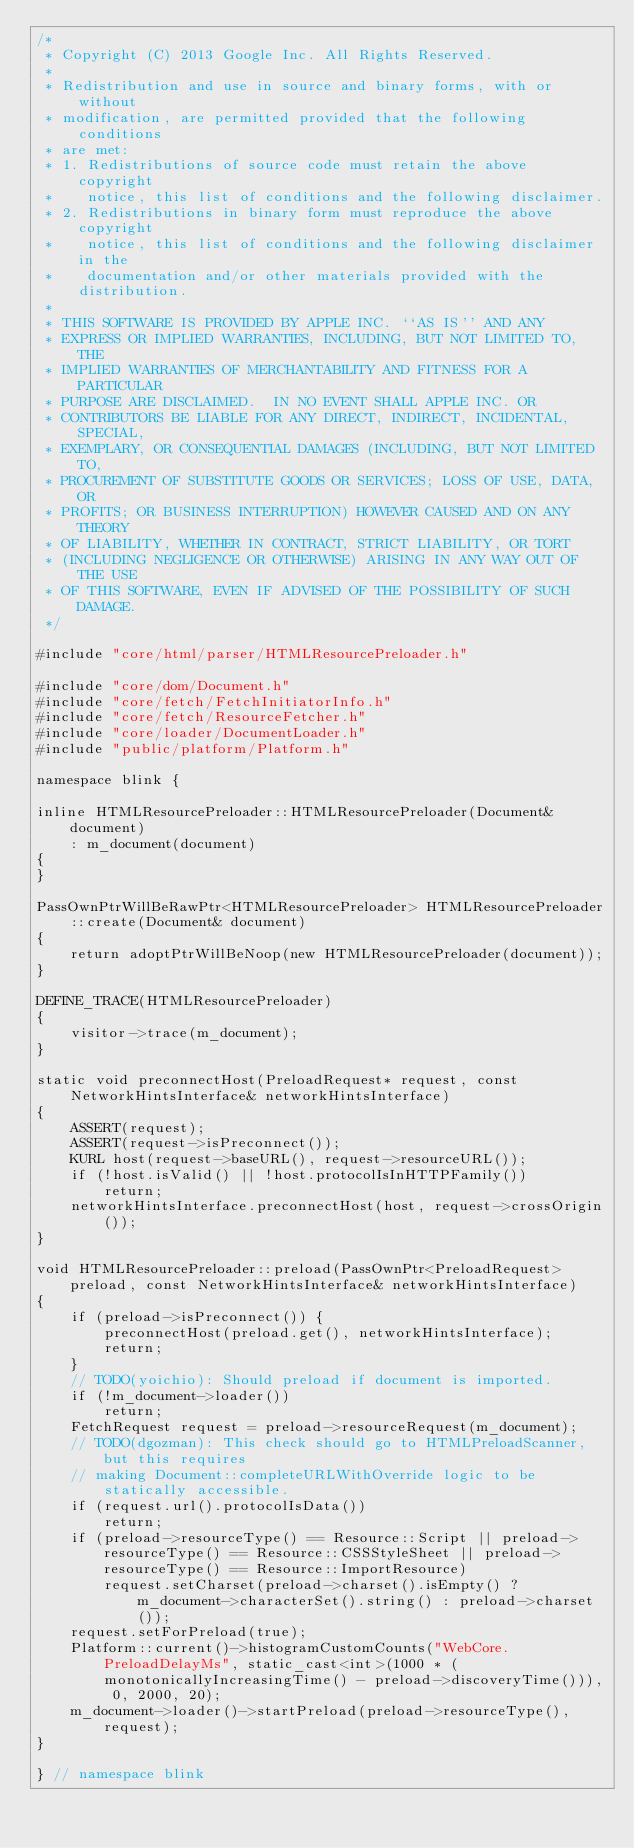Convert code to text. <code><loc_0><loc_0><loc_500><loc_500><_C++_>/*
 * Copyright (C) 2013 Google Inc. All Rights Reserved.
 *
 * Redistribution and use in source and binary forms, with or without
 * modification, are permitted provided that the following conditions
 * are met:
 * 1. Redistributions of source code must retain the above copyright
 *    notice, this list of conditions and the following disclaimer.
 * 2. Redistributions in binary form must reproduce the above copyright
 *    notice, this list of conditions and the following disclaimer in the
 *    documentation and/or other materials provided with the distribution.
 *
 * THIS SOFTWARE IS PROVIDED BY APPLE INC. ``AS IS'' AND ANY
 * EXPRESS OR IMPLIED WARRANTIES, INCLUDING, BUT NOT LIMITED TO, THE
 * IMPLIED WARRANTIES OF MERCHANTABILITY AND FITNESS FOR A PARTICULAR
 * PURPOSE ARE DISCLAIMED.  IN NO EVENT SHALL APPLE INC. OR
 * CONTRIBUTORS BE LIABLE FOR ANY DIRECT, INDIRECT, INCIDENTAL, SPECIAL,
 * EXEMPLARY, OR CONSEQUENTIAL DAMAGES (INCLUDING, BUT NOT LIMITED TO,
 * PROCUREMENT OF SUBSTITUTE GOODS OR SERVICES; LOSS OF USE, DATA, OR
 * PROFITS; OR BUSINESS INTERRUPTION) HOWEVER CAUSED AND ON ANY THEORY
 * OF LIABILITY, WHETHER IN CONTRACT, STRICT LIABILITY, OR TORT
 * (INCLUDING NEGLIGENCE OR OTHERWISE) ARISING IN ANY WAY OUT OF THE USE
 * OF THIS SOFTWARE, EVEN IF ADVISED OF THE POSSIBILITY OF SUCH DAMAGE.
 */

#include "core/html/parser/HTMLResourcePreloader.h"

#include "core/dom/Document.h"
#include "core/fetch/FetchInitiatorInfo.h"
#include "core/fetch/ResourceFetcher.h"
#include "core/loader/DocumentLoader.h"
#include "public/platform/Platform.h"

namespace blink {

inline HTMLResourcePreloader::HTMLResourcePreloader(Document& document)
    : m_document(document)
{
}

PassOwnPtrWillBeRawPtr<HTMLResourcePreloader> HTMLResourcePreloader::create(Document& document)
{
    return adoptPtrWillBeNoop(new HTMLResourcePreloader(document));
}

DEFINE_TRACE(HTMLResourcePreloader)
{
    visitor->trace(m_document);
}

static void preconnectHost(PreloadRequest* request, const NetworkHintsInterface& networkHintsInterface)
{
    ASSERT(request);
    ASSERT(request->isPreconnect());
    KURL host(request->baseURL(), request->resourceURL());
    if (!host.isValid() || !host.protocolIsInHTTPFamily())
        return;
    networkHintsInterface.preconnectHost(host, request->crossOrigin());
}

void HTMLResourcePreloader::preload(PassOwnPtr<PreloadRequest> preload, const NetworkHintsInterface& networkHintsInterface)
{
    if (preload->isPreconnect()) {
        preconnectHost(preload.get(), networkHintsInterface);
        return;
    }
    // TODO(yoichio): Should preload if document is imported.
    if (!m_document->loader())
        return;
    FetchRequest request = preload->resourceRequest(m_document);
    // TODO(dgozman): This check should go to HTMLPreloadScanner, but this requires
    // making Document::completeURLWithOverride logic to be statically accessible.
    if (request.url().protocolIsData())
        return;
    if (preload->resourceType() == Resource::Script || preload->resourceType() == Resource::CSSStyleSheet || preload->resourceType() == Resource::ImportResource)
        request.setCharset(preload->charset().isEmpty() ? m_document->characterSet().string() : preload->charset());
    request.setForPreload(true);
    Platform::current()->histogramCustomCounts("WebCore.PreloadDelayMs", static_cast<int>(1000 * (monotonicallyIncreasingTime() - preload->discoveryTime())), 0, 2000, 20);
    m_document->loader()->startPreload(preload->resourceType(), request);
}

} // namespace blink
</code> 